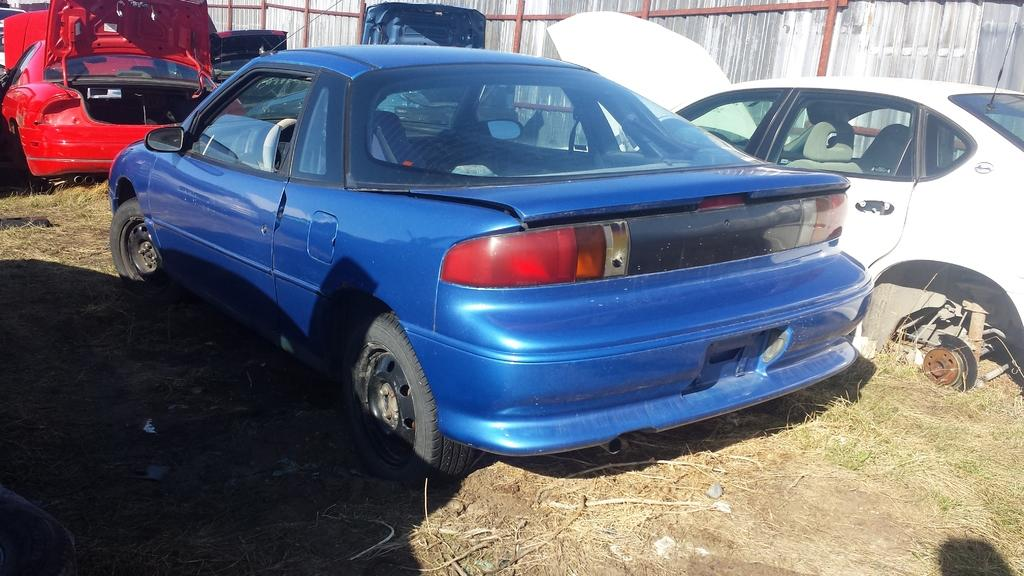What is the main subject of the image? The main subject of the image is a group of vehicles. How are the vehicles positioned in the image? The vehicles are parked on the ground. What can be seen in the background of the image? There is a fence and a group of poles associated with the fence in the background. How many beds can be seen in the image? There are no beds present in the image. What color is the sky in the image? The provided facts do not mention the color of the sky, and there is no indication of the sky being visible in the image. 